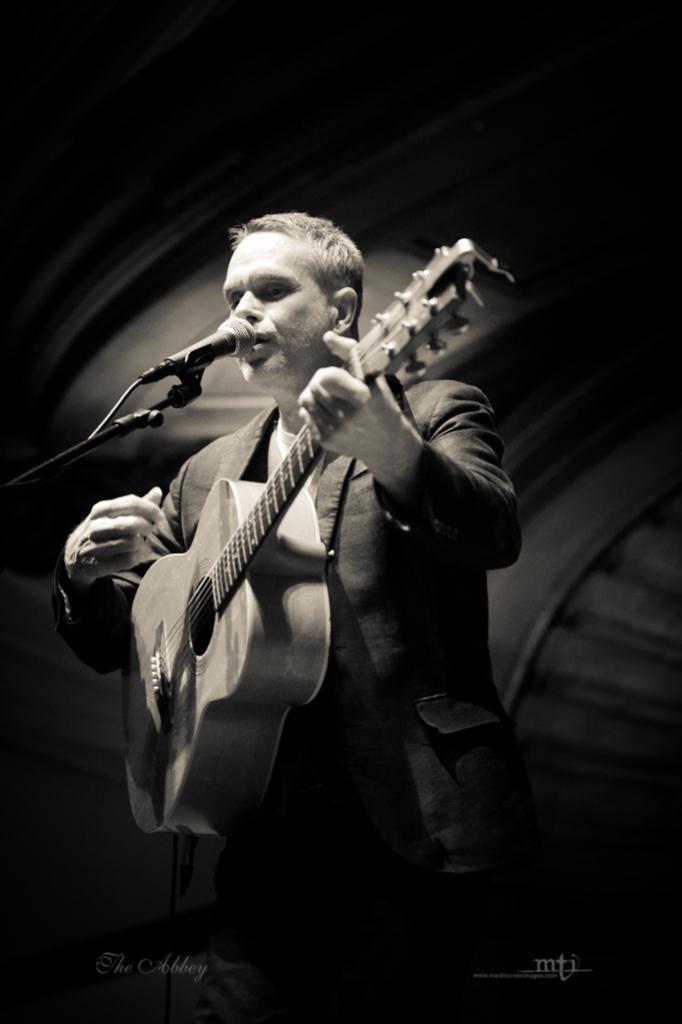What is the main subject of the image? The main subject of the image is a man. What is the man doing in the image? The man is standing, holding a guitar, and singing. What object is the man using to amplify his voice? There is a microphone in the image. What is the man wearing in the image? The man is wearing a suit. How many clovers can be seen growing near the man in the image? There are no clovers visible in the image. What type of ticket does the man have for his performance? There is no information about a ticket in the image. 